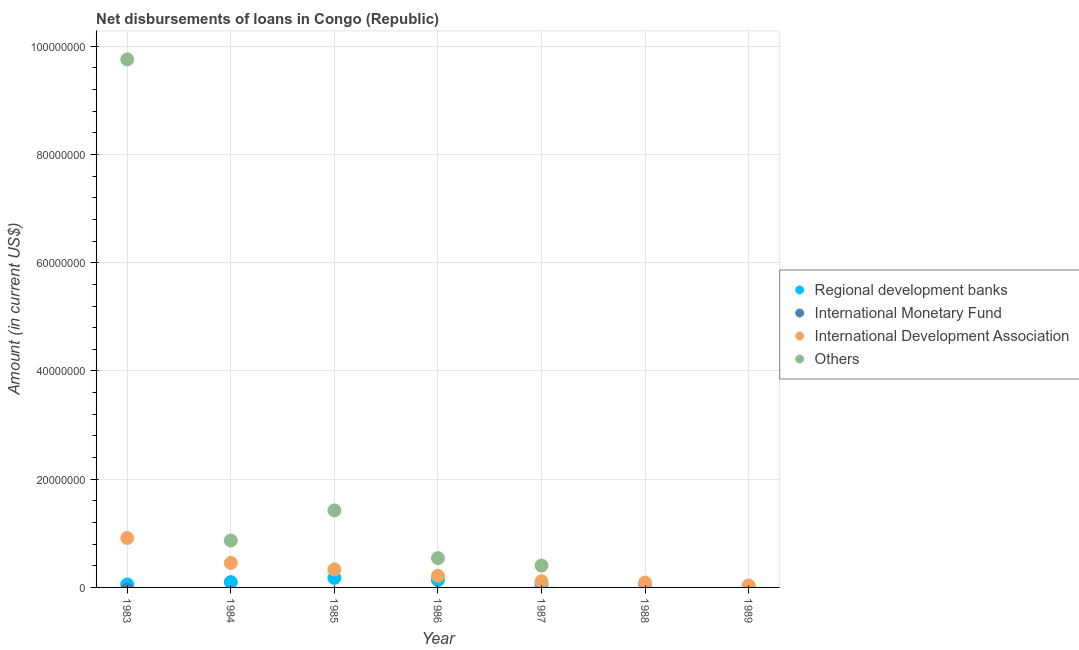How many different coloured dotlines are there?
Offer a very short reply. 3. What is the amount of loan disimbursed by international development association in 1984?
Your response must be concise. 4.52e+06. Across all years, what is the maximum amount of loan disimbursed by regional development banks?
Your answer should be very brief. 1.76e+06. Across all years, what is the minimum amount of loan disimbursed by other organisations?
Offer a terse response. 0. What is the total amount of loan disimbursed by international monetary fund in the graph?
Your answer should be very brief. 0. What is the difference between the amount of loan disimbursed by other organisations in 1983 and that in 1984?
Ensure brevity in your answer.  8.89e+07. What is the difference between the amount of loan disimbursed by other organisations in 1987 and the amount of loan disimbursed by regional development banks in 1983?
Give a very brief answer. 3.49e+06. What is the average amount of loan disimbursed by international monetary fund per year?
Offer a very short reply. 0. In the year 1989, what is the difference between the amount of loan disimbursed by international development association and amount of loan disimbursed by regional development banks?
Your answer should be very brief. 3.11e+05. What is the ratio of the amount of loan disimbursed by other organisations in 1985 to that in 1986?
Your answer should be compact. 2.63. Is the amount of loan disimbursed by other organisations in 1983 less than that in 1984?
Provide a succinct answer. No. What is the difference between the highest and the second highest amount of loan disimbursed by other organisations?
Offer a terse response. 8.33e+07. What is the difference between the highest and the lowest amount of loan disimbursed by regional development banks?
Your answer should be compact. 1.72e+06. Is it the case that in every year, the sum of the amount of loan disimbursed by regional development banks and amount of loan disimbursed by international monetary fund is greater than the amount of loan disimbursed by international development association?
Your answer should be very brief. No. Does the amount of loan disimbursed by international monetary fund monotonically increase over the years?
Give a very brief answer. No. Is the amount of loan disimbursed by other organisations strictly greater than the amount of loan disimbursed by regional development banks over the years?
Offer a terse response. No. How many years are there in the graph?
Offer a very short reply. 7. What is the difference between two consecutive major ticks on the Y-axis?
Provide a succinct answer. 2.00e+07. Does the graph contain any zero values?
Keep it short and to the point. Yes. Does the graph contain grids?
Offer a terse response. Yes. Where does the legend appear in the graph?
Provide a short and direct response. Center right. How many legend labels are there?
Give a very brief answer. 4. What is the title of the graph?
Offer a terse response. Net disbursements of loans in Congo (Republic). What is the label or title of the X-axis?
Your response must be concise. Year. What is the label or title of the Y-axis?
Make the answer very short. Amount (in current US$). What is the Amount (in current US$) of Regional development banks in 1983?
Provide a short and direct response. 5.50e+05. What is the Amount (in current US$) in International Development Association in 1983?
Provide a short and direct response. 9.13e+06. What is the Amount (in current US$) of Others in 1983?
Offer a very short reply. 9.76e+07. What is the Amount (in current US$) in Regional development banks in 1984?
Provide a succinct answer. 9.76e+05. What is the Amount (in current US$) of International Monetary Fund in 1984?
Make the answer very short. 0. What is the Amount (in current US$) of International Development Association in 1984?
Offer a terse response. 4.52e+06. What is the Amount (in current US$) of Others in 1984?
Your response must be concise. 8.66e+06. What is the Amount (in current US$) of Regional development banks in 1985?
Offer a very short reply. 1.76e+06. What is the Amount (in current US$) in International Monetary Fund in 1985?
Provide a short and direct response. 0. What is the Amount (in current US$) of International Development Association in 1985?
Ensure brevity in your answer.  3.34e+06. What is the Amount (in current US$) in Others in 1985?
Offer a terse response. 1.42e+07. What is the Amount (in current US$) of Regional development banks in 1986?
Give a very brief answer. 1.36e+06. What is the Amount (in current US$) in International Development Association in 1986?
Provide a succinct answer. 2.15e+06. What is the Amount (in current US$) of Others in 1986?
Ensure brevity in your answer.  5.42e+06. What is the Amount (in current US$) of Regional development banks in 1987?
Make the answer very short. 5.61e+05. What is the Amount (in current US$) in International Development Association in 1987?
Offer a very short reply. 1.14e+06. What is the Amount (in current US$) of Others in 1987?
Your answer should be compact. 4.04e+06. What is the Amount (in current US$) in Regional development banks in 1988?
Offer a very short reply. 5.84e+05. What is the Amount (in current US$) of International Monetary Fund in 1988?
Offer a terse response. 0. What is the Amount (in current US$) of International Development Association in 1988?
Your answer should be very brief. 8.98e+05. What is the Amount (in current US$) in Others in 1988?
Ensure brevity in your answer.  0. What is the Amount (in current US$) in International Monetary Fund in 1989?
Ensure brevity in your answer.  0. What is the Amount (in current US$) in International Development Association in 1989?
Offer a very short reply. 3.51e+05. What is the Amount (in current US$) of Others in 1989?
Provide a short and direct response. 0. Across all years, what is the maximum Amount (in current US$) of Regional development banks?
Provide a succinct answer. 1.76e+06. Across all years, what is the maximum Amount (in current US$) in International Development Association?
Make the answer very short. 9.13e+06. Across all years, what is the maximum Amount (in current US$) of Others?
Offer a terse response. 9.76e+07. Across all years, what is the minimum Amount (in current US$) of International Development Association?
Offer a very short reply. 3.51e+05. What is the total Amount (in current US$) in Regional development banks in the graph?
Make the answer very short. 5.83e+06. What is the total Amount (in current US$) of International Monetary Fund in the graph?
Your response must be concise. 0. What is the total Amount (in current US$) in International Development Association in the graph?
Offer a terse response. 2.15e+07. What is the total Amount (in current US$) of Others in the graph?
Offer a terse response. 1.30e+08. What is the difference between the Amount (in current US$) of Regional development banks in 1983 and that in 1984?
Your response must be concise. -4.26e+05. What is the difference between the Amount (in current US$) of International Development Association in 1983 and that in 1984?
Offer a terse response. 4.61e+06. What is the difference between the Amount (in current US$) of Others in 1983 and that in 1984?
Keep it short and to the point. 8.89e+07. What is the difference between the Amount (in current US$) of Regional development banks in 1983 and that in 1985?
Provide a succinct answer. -1.21e+06. What is the difference between the Amount (in current US$) in International Development Association in 1983 and that in 1985?
Make the answer very short. 5.80e+06. What is the difference between the Amount (in current US$) in Others in 1983 and that in 1985?
Give a very brief answer. 8.33e+07. What is the difference between the Amount (in current US$) of Regional development banks in 1983 and that in 1986?
Provide a short and direct response. -8.10e+05. What is the difference between the Amount (in current US$) of International Development Association in 1983 and that in 1986?
Offer a terse response. 6.98e+06. What is the difference between the Amount (in current US$) in Others in 1983 and that in 1986?
Keep it short and to the point. 9.22e+07. What is the difference between the Amount (in current US$) in Regional development banks in 1983 and that in 1987?
Give a very brief answer. -1.10e+04. What is the difference between the Amount (in current US$) in International Development Association in 1983 and that in 1987?
Offer a very short reply. 8.00e+06. What is the difference between the Amount (in current US$) in Others in 1983 and that in 1987?
Offer a terse response. 9.35e+07. What is the difference between the Amount (in current US$) in Regional development banks in 1983 and that in 1988?
Offer a very short reply. -3.40e+04. What is the difference between the Amount (in current US$) of International Development Association in 1983 and that in 1988?
Provide a short and direct response. 8.24e+06. What is the difference between the Amount (in current US$) in Regional development banks in 1983 and that in 1989?
Keep it short and to the point. 5.10e+05. What is the difference between the Amount (in current US$) in International Development Association in 1983 and that in 1989?
Your response must be concise. 8.78e+06. What is the difference between the Amount (in current US$) of Regional development banks in 1984 and that in 1985?
Make the answer very short. -7.82e+05. What is the difference between the Amount (in current US$) in International Development Association in 1984 and that in 1985?
Offer a very short reply. 1.18e+06. What is the difference between the Amount (in current US$) in Others in 1984 and that in 1985?
Keep it short and to the point. -5.57e+06. What is the difference between the Amount (in current US$) in Regional development banks in 1984 and that in 1986?
Offer a terse response. -3.84e+05. What is the difference between the Amount (in current US$) of International Development Association in 1984 and that in 1986?
Your answer should be compact. 2.37e+06. What is the difference between the Amount (in current US$) in Others in 1984 and that in 1986?
Provide a short and direct response. 3.24e+06. What is the difference between the Amount (in current US$) of Regional development banks in 1984 and that in 1987?
Provide a short and direct response. 4.15e+05. What is the difference between the Amount (in current US$) of International Development Association in 1984 and that in 1987?
Give a very brief answer. 3.38e+06. What is the difference between the Amount (in current US$) in Others in 1984 and that in 1987?
Your answer should be very brief. 4.62e+06. What is the difference between the Amount (in current US$) of Regional development banks in 1984 and that in 1988?
Provide a short and direct response. 3.92e+05. What is the difference between the Amount (in current US$) in International Development Association in 1984 and that in 1988?
Offer a very short reply. 3.62e+06. What is the difference between the Amount (in current US$) of Regional development banks in 1984 and that in 1989?
Your answer should be very brief. 9.36e+05. What is the difference between the Amount (in current US$) in International Development Association in 1984 and that in 1989?
Offer a very short reply. 4.17e+06. What is the difference between the Amount (in current US$) in Regional development banks in 1985 and that in 1986?
Your response must be concise. 3.98e+05. What is the difference between the Amount (in current US$) of International Development Association in 1985 and that in 1986?
Your answer should be compact. 1.19e+06. What is the difference between the Amount (in current US$) of Others in 1985 and that in 1986?
Your answer should be compact. 8.81e+06. What is the difference between the Amount (in current US$) in Regional development banks in 1985 and that in 1987?
Your answer should be very brief. 1.20e+06. What is the difference between the Amount (in current US$) in International Development Association in 1985 and that in 1987?
Offer a very short reply. 2.20e+06. What is the difference between the Amount (in current US$) in Others in 1985 and that in 1987?
Keep it short and to the point. 1.02e+07. What is the difference between the Amount (in current US$) in Regional development banks in 1985 and that in 1988?
Your answer should be compact. 1.17e+06. What is the difference between the Amount (in current US$) of International Development Association in 1985 and that in 1988?
Offer a terse response. 2.44e+06. What is the difference between the Amount (in current US$) in Regional development banks in 1985 and that in 1989?
Your answer should be compact. 1.72e+06. What is the difference between the Amount (in current US$) of International Development Association in 1985 and that in 1989?
Provide a short and direct response. 2.99e+06. What is the difference between the Amount (in current US$) of Regional development banks in 1986 and that in 1987?
Offer a very short reply. 7.99e+05. What is the difference between the Amount (in current US$) in International Development Association in 1986 and that in 1987?
Make the answer very short. 1.01e+06. What is the difference between the Amount (in current US$) in Others in 1986 and that in 1987?
Your response must be concise. 1.38e+06. What is the difference between the Amount (in current US$) of Regional development banks in 1986 and that in 1988?
Offer a very short reply. 7.76e+05. What is the difference between the Amount (in current US$) of International Development Association in 1986 and that in 1988?
Provide a succinct answer. 1.25e+06. What is the difference between the Amount (in current US$) in Regional development banks in 1986 and that in 1989?
Your response must be concise. 1.32e+06. What is the difference between the Amount (in current US$) in International Development Association in 1986 and that in 1989?
Your answer should be compact. 1.80e+06. What is the difference between the Amount (in current US$) of Regional development banks in 1987 and that in 1988?
Your response must be concise. -2.30e+04. What is the difference between the Amount (in current US$) of International Development Association in 1987 and that in 1988?
Make the answer very short. 2.38e+05. What is the difference between the Amount (in current US$) of Regional development banks in 1987 and that in 1989?
Ensure brevity in your answer.  5.21e+05. What is the difference between the Amount (in current US$) in International Development Association in 1987 and that in 1989?
Provide a short and direct response. 7.85e+05. What is the difference between the Amount (in current US$) in Regional development banks in 1988 and that in 1989?
Give a very brief answer. 5.44e+05. What is the difference between the Amount (in current US$) in International Development Association in 1988 and that in 1989?
Offer a very short reply. 5.47e+05. What is the difference between the Amount (in current US$) of Regional development banks in 1983 and the Amount (in current US$) of International Development Association in 1984?
Provide a short and direct response. -3.97e+06. What is the difference between the Amount (in current US$) of Regional development banks in 1983 and the Amount (in current US$) of Others in 1984?
Your answer should be very brief. -8.11e+06. What is the difference between the Amount (in current US$) in International Development Association in 1983 and the Amount (in current US$) in Others in 1984?
Make the answer very short. 4.71e+05. What is the difference between the Amount (in current US$) of Regional development banks in 1983 and the Amount (in current US$) of International Development Association in 1985?
Keep it short and to the point. -2.79e+06. What is the difference between the Amount (in current US$) of Regional development banks in 1983 and the Amount (in current US$) of Others in 1985?
Provide a short and direct response. -1.37e+07. What is the difference between the Amount (in current US$) in International Development Association in 1983 and the Amount (in current US$) in Others in 1985?
Offer a terse response. -5.10e+06. What is the difference between the Amount (in current US$) in Regional development banks in 1983 and the Amount (in current US$) in International Development Association in 1986?
Give a very brief answer. -1.60e+06. What is the difference between the Amount (in current US$) of Regional development banks in 1983 and the Amount (in current US$) of Others in 1986?
Offer a very short reply. -4.87e+06. What is the difference between the Amount (in current US$) of International Development Association in 1983 and the Amount (in current US$) of Others in 1986?
Provide a short and direct response. 3.71e+06. What is the difference between the Amount (in current US$) in Regional development banks in 1983 and the Amount (in current US$) in International Development Association in 1987?
Ensure brevity in your answer.  -5.86e+05. What is the difference between the Amount (in current US$) of Regional development banks in 1983 and the Amount (in current US$) of Others in 1987?
Your answer should be very brief. -3.49e+06. What is the difference between the Amount (in current US$) in International Development Association in 1983 and the Amount (in current US$) in Others in 1987?
Make the answer very short. 5.10e+06. What is the difference between the Amount (in current US$) of Regional development banks in 1983 and the Amount (in current US$) of International Development Association in 1988?
Keep it short and to the point. -3.48e+05. What is the difference between the Amount (in current US$) of Regional development banks in 1983 and the Amount (in current US$) of International Development Association in 1989?
Your answer should be compact. 1.99e+05. What is the difference between the Amount (in current US$) of Regional development banks in 1984 and the Amount (in current US$) of International Development Association in 1985?
Keep it short and to the point. -2.36e+06. What is the difference between the Amount (in current US$) of Regional development banks in 1984 and the Amount (in current US$) of Others in 1985?
Keep it short and to the point. -1.33e+07. What is the difference between the Amount (in current US$) of International Development Association in 1984 and the Amount (in current US$) of Others in 1985?
Provide a short and direct response. -9.71e+06. What is the difference between the Amount (in current US$) in Regional development banks in 1984 and the Amount (in current US$) in International Development Association in 1986?
Your answer should be very brief. -1.17e+06. What is the difference between the Amount (in current US$) in Regional development banks in 1984 and the Amount (in current US$) in Others in 1986?
Make the answer very short. -4.44e+06. What is the difference between the Amount (in current US$) in International Development Association in 1984 and the Amount (in current US$) in Others in 1986?
Offer a very short reply. -8.98e+05. What is the difference between the Amount (in current US$) of Regional development banks in 1984 and the Amount (in current US$) of Others in 1987?
Provide a short and direct response. -3.06e+06. What is the difference between the Amount (in current US$) in International Development Association in 1984 and the Amount (in current US$) in Others in 1987?
Your response must be concise. 4.83e+05. What is the difference between the Amount (in current US$) of Regional development banks in 1984 and the Amount (in current US$) of International Development Association in 1988?
Offer a terse response. 7.80e+04. What is the difference between the Amount (in current US$) of Regional development banks in 1984 and the Amount (in current US$) of International Development Association in 1989?
Make the answer very short. 6.25e+05. What is the difference between the Amount (in current US$) of Regional development banks in 1985 and the Amount (in current US$) of International Development Association in 1986?
Ensure brevity in your answer.  -3.91e+05. What is the difference between the Amount (in current US$) in Regional development banks in 1985 and the Amount (in current US$) in Others in 1986?
Offer a terse response. -3.66e+06. What is the difference between the Amount (in current US$) of International Development Association in 1985 and the Amount (in current US$) of Others in 1986?
Offer a terse response. -2.08e+06. What is the difference between the Amount (in current US$) in Regional development banks in 1985 and the Amount (in current US$) in International Development Association in 1987?
Your response must be concise. 6.22e+05. What is the difference between the Amount (in current US$) of Regional development banks in 1985 and the Amount (in current US$) of Others in 1987?
Provide a short and direct response. -2.28e+06. What is the difference between the Amount (in current US$) of International Development Association in 1985 and the Amount (in current US$) of Others in 1987?
Provide a succinct answer. -7.01e+05. What is the difference between the Amount (in current US$) of Regional development banks in 1985 and the Amount (in current US$) of International Development Association in 1988?
Provide a succinct answer. 8.60e+05. What is the difference between the Amount (in current US$) of Regional development banks in 1985 and the Amount (in current US$) of International Development Association in 1989?
Offer a very short reply. 1.41e+06. What is the difference between the Amount (in current US$) of Regional development banks in 1986 and the Amount (in current US$) of International Development Association in 1987?
Ensure brevity in your answer.  2.24e+05. What is the difference between the Amount (in current US$) of Regional development banks in 1986 and the Amount (in current US$) of Others in 1987?
Provide a succinct answer. -2.68e+06. What is the difference between the Amount (in current US$) of International Development Association in 1986 and the Amount (in current US$) of Others in 1987?
Provide a succinct answer. -1.89e+06. What is the difference between the Amount (in current US$) in Regional development banks in 1986 and the Amount (in current US$) in International Development Association in 1988?
Give a very brief answer. 4.62e+05. What is the difference between the Amount (in current US$) of Regional development banks in 1986 and the Amount (in current US$) of International Development Association in 1989?
Give a very brief answer. 1.01e+06. What is the difference between the Amount (in current US$) of Regional development banks in 1987 and the Amount (in current US$) of International Development Association in 1988?
Provide a short and direct response. -3.37e+05. What is the difference between the Amount (in current US$) in Regional development banks in 1988 and the Amount (in current US$) in International Development Association in 1989?
Make the answer very short. 2.33e+05. What is the average Amount (in current US$) in Regional development banks per year?
Offer a very short reply. 8.33e+05. What is the average Amount (in current US$) of International Development Association per year?
Your response must be concise. 3.08e+06. What is the average Amount (in current US$) in Others per year?
Give a very brief answer. 1.86e+07. In the year 1983, what is the difference between the Amount (in current US$) in Regional development banks and Amount (in current US$) in International Development Association?
Provide a short and direct response. -8.58e+06. In the year 1983, what is the difference between the Amount (in current US$) of Regional development banks and Amount (in current US$) of Others?
Give a very brief answer. -9.70e+07. In the year 1983, what is the difference between the Amount (in current US$) of International Development Association and Amount (in current US$) of Others?
Your response must be concise. -8.84e+07. In the year 1984, what is the difference between the Amount (in current US$) in Regional development banks and Amount (in current US$) in International Development Association?
Your answer should be very brief. -3.54e+06. In the year 1984, what is the difference between the Amount (in current US$) in Regional development banks and Amount (in current US$) in Others?
Your response must be concise. -7.69e+06. In the year 1984, what is the difference between the Amount (in current US$) of International Development Association and Amount (in current US$) of Others?
Your response must be concise. -4.14e+06. In the year 1985, what is the difference between the Amount (in current US$) of Regional development banks and Amount (in current US$) of International Development Association?
Make the answer very short. -1.58e+06. In the year 1985, what is the difference between the Amount (in current US$) of Regional development banks and Amount (in current US$) of Others?
Make the answer very short. -1.25e+07. In the year 1985, what is the difference between the Amount (in current US$) in International Development Association and Amount (in current US$) in Others?
Keep it short and to the point. -1.09e+07. In the year 1986, what is the difference between the Amount (in current US$) of Regional development banks and Amount (in current US$) of International Development Association?
Provide a succinct answer. -7.89e+05. In the year 1986, what is the difference between the Amount (in current US$) of Regional development banks and Amount (in current US$) of Others?
Provide a succinct answer. -4.06e+06. In the year 1986, what is the difference between the Amount (in current US$) of International Development Association and Amount (in current US$) of Others?
Give a very brief answer. -3.27e+06. In the year 1987, what is the difference between the Amount (in current US$) of Regional development banks and Amount (in current US$) of International Development Association?
Provide a succinct answer. -5.75e+05. In the year 1987, what is the difference between the Amount (in current US$) in Regional development banks and Amount (in current US$) in Others?
Your answer should be very brief. -3.48e+06. In the year 1987, what is the difference between the Amount (in current US$) of International Development Association and Amount (in current US$) of Others?
Offer a terse response. -2.90e+06. In the year 1988, what is the difference between the Amount (in current US$) of Regional development banks and Amount (in current US$) of International Development Association?
Your answer should be very brief. -3.14e+05. In the year 1989, what is the difference between the Amount (in current US$) in Regional development banks and Amount (in current US$) in International Development Association?
Provide a succinct answer. -3.11e+05. What is the ratio of the Amount (in current US$) of Regional development banks in 1983 to that in 1984?
Offer a very short reply. 0.56. What is the ratio of the Amount (in current US$) of International Development Association in 1983 to that in 1984?
Your answer should be very brief. 2.02. What is the ratio of the Amount (in current US$) of Others in 1983 to that in 1984?
Your answer should be very brief. 11.26. What is the ratio of the Amount (in current US$) in Regional development banks in 1983 to that in 1985?
Ensure brevity in your answer.  0.31. What is the ratio of the Amount (in current US$) in International Development Association in 1983 to that in 1985?
Ensure brevity in your answer.  2.74. What is the ratio of the Amount (in current US$) of Others in 1983 to that in 1985?
Offer a very short reply. 6.86. What is the ratio of the Amount (in current US$) of Regional development banks in 1983 to that in 1986?
Provide a succinct answer. 0.4. What is the ratio of the Amount (in current US$) in International Development Association in 1983 to that in 1986?
Your answer should be compact. 4.25. What is the ratio of the Amount (in current US$) in Others in 1983 to that in 1986?
Offer a terse response. 18.01. What is the ratio of the Amount (in current US$) in Regional development banks in 1983 to that in 1987?
Your answer should be compact. 0.98. What is the ratio of the Amount (in current US$) in International Development Association in 1983 to that in 1987?
Your response must be concise. 8.04. What is the ratio of the Amount (in current US$) in Others in 1983 to that in 1987?
Your response must be concise. 24.16. What is the ratio of the Amount (in current US$) in Regional development banks in 1983 to that in 1988?
Keep it short and to the point. 0.94. What is the ratio of the Amount (in current US$) of International Development Association in 1983 to that in 1988?
Keep it short and to the point. 10.17. What is the ratio of the Amount (in current US$) of Regional development banks in 1983 to that in 1989?
Your answer should be very brief. 13.75. What is the ratio of the Amount (in current US$) in International Development Association in 1983 to that in 1989?
Give a very brief answer. 26.02. What is the ratio of the Amount (in current US$) in Regional development banks in 1984 to that in 1985?
Make the answer very short. 0.56. What is the ratio of the Amount (in current US$) in International Development Association in 1984 to that in 1985?
Provide a succinct answer. 1.35. What is the ratio of the Amount (in current US$) of Others in 1984 to that in 1985?
Give a very brief answer. 0.61. What is the ratio of the Amount (in current US$) in Regional development banks in 1984 to that in 1986?
Offer a very short reply. 0.72. What is the ratio of the Amount (in current US$) of International Development Association in 1984 to that in 1986?
Provide a succinct answer. 2.1. What is the ratio of the Amount (in current US$) in Others in 1984 to that in 1986?
Your answer should be very brief. 1.6. What is the ratio of the Amount (in current US$) in Regional development banks in 1984 to that in 1987?
Provide a short and direct response. 1.74. What is the ratio of the Amount (in current US$) in International Development Association in 1984 to that in 1987?
Your answer should be very brief. 3.98. What is the ratio of the Amount (in current US$) in Others in 1984 to that in 1987?
Offer a terse response. 2.15. What is the ratio of the Amount (in current US$) in Regional development banks in 1984 to that in 1988?
Ensure brevity in your answer.  1.67. What is the ratio of the Amount (in current US$) of International Development Association in 1984 to that in 1988?
Ensure brevity in your answer.  5.03. What is the ratio of the Amount (in current US$) in Regional development banks in 1984 to that in 1989?
Provide a short and direct response. 24.4. What is the ratio of the Amount (in current US$) of International Development Association in 1984 to that in 1989?
Make the answer very short. 12.88. What is the ratio of the Amount (in current US$) of Regional development banks in 1985 to that in 1986?
Your response must be concise. 1.29. What is the ratio of the Amount (in current US$) in International Development Association in 1985 to that in 1986?
Ensure brevity in your answer.  1.55. What is the ratio of the Amount (in current US$) in Others in 1985 to that in 1986?
Provide a short and direct response. 2.63. What is the ratio of the Amount (in current US$) in Regional development banks in 1985 to that in 1987?
Make the answer very short. 3.13. What is the ratio of the Amount (in current US$) of International Development Association in 1985 to that in 1987?
Give a very brief answer. 2.94. What is the ratio of the Amount (in current US$) of Others in 1985 to that in 1987?
Ensure brevity in your answer.  3.52. What is the ratio of the Amount (in current US$) of Regional development banks in 1985 to that in 1988?
Your answer should be very brief. 3.01. What is the ratio of the Amount (in current US$) in International Development Association in 1985 to that in 1988?
Your response must be concise. 3.72. What is the ratio of the Amount (in current US$) in Regional development banks in 1985 to that in 1989?
Ensure brevity in your answer.  43.95. What is the ratio of the Amount (in current US$) of International Development Association in 1985 to that in 1989?
Ensure brevity in your answer.  9.51. What is the ratio of the Amount (in current US$) of Regional development banks in 1986 to that in 1987?
Ensure brevity in your answer.  2.42. What is the ratio of the Amount (in current US$) of International Development Association in 1986 to that in 1987?
Your answer should be compact. 1.89. What is the ratio of the Amount (in current US$) in Others in 1986 to that in 1987?
Offer a very short reply. 1.34. What is the ratio of the Amount (in current US$) of Regional development banks in 1986 to that in 1988?
Your answer should be very brief. 2.33. What is the ratio of the Amount (in current US$) in International Development Association in 1986 to that in 1988?
Make the answer very short. 2.39. What is the ratio of the Amount (in current US$) in Regional development banks in 1986 to that in 1989?
Your answer should be compact. 34. What is the ratio of the Amount (in current US$) in International Development Association in 1986 to that in 1989?
Your answer should be very brief. 6.12. What is the ratio of the Amount (in current US$) of Regional development banks in 1987 to that in 1988?
Your answer should be compact. 0.96. What is the ratio of the Amount (in current US$) in International Development Association in 1987 to that in 1988?
Your answer should be very brief. 1.26. What is the ratio of the Amount (in current US$) in Regional development banks in 1987 to that in 1989?
Make the answer very short. 14.03. What is the ratio of the Amount (in current US$) in International Development Association in 1987 to that in 1989?
Your answer should be very brief. 3.24. What is the ratio of the Amount (in current US$) of International Development Association in 1988 to that in 1989?
Provide a succinct answer. 2.56. What is the difference between the highest and the second highest Amount (in current US$) of Regional development banks?
Your answer should be very brief. 3.98e+05. What is the difference between the highest and the second highest Amount (in current US$) in International Development Association?
Make the answer very short. 4.61e+06. What is the difference between the highest and the second highest Amount (in current US$) of Others?
Your answer should be very brief. 8.33e+07. What is the difference between the highest and the lowest Amount (in current US$) of Regional development banks?
Keep it short and to the point. 1.72e+06. What is the difference between the highest and the lowest Amount (in current US$) of International Development Association?
Your answer should be compact. 8.78e+06. What is the difference between the highest and the lowest Amount (in current US$) of Others?
Make the answer very short. 9.76e+07. 